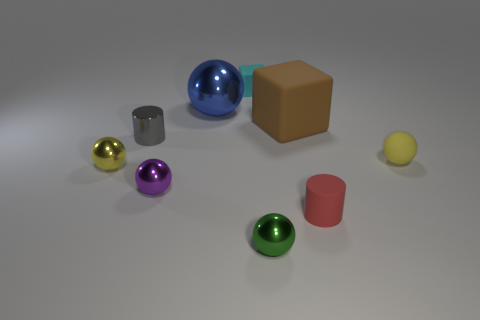There is a metallic thing that is on the left side of the gray metal cylinder; what is its size?
Make the answer very short. Small. Do the yellow thing to the right of the blue shiny thing and the yellow ball that is to the left of the cyan thing have the same size?
Ensure brevity in your answer.  Yes. What number of tiny green objects are the same material as the brown block?
Provide a succinct answer. 0. The small metal cylinder is what color?
Provide a short and direct response. Gray. There is a small gray cylinder; are there any yellow objects on the right side of it?
Keep it short and to the point. Yes. How many shiny balls have the same color as the small matte sphere?
Give a very brief answer. 1. There is a yellow ball to the left of the tiny yellow thing right of the red rubber object; what size is it?
Make the answer very short. Small. What shape is the small cyan thing?
Provide a succinct answer. Cube. What is the tiny yellow object on the left side of the big brown cube made of?
Provide a succinct answer. Metal. The cylinder that is behind the yellow ball left of the sphere that is behind the brown block is what color?
Make the answer very short. Gray. 